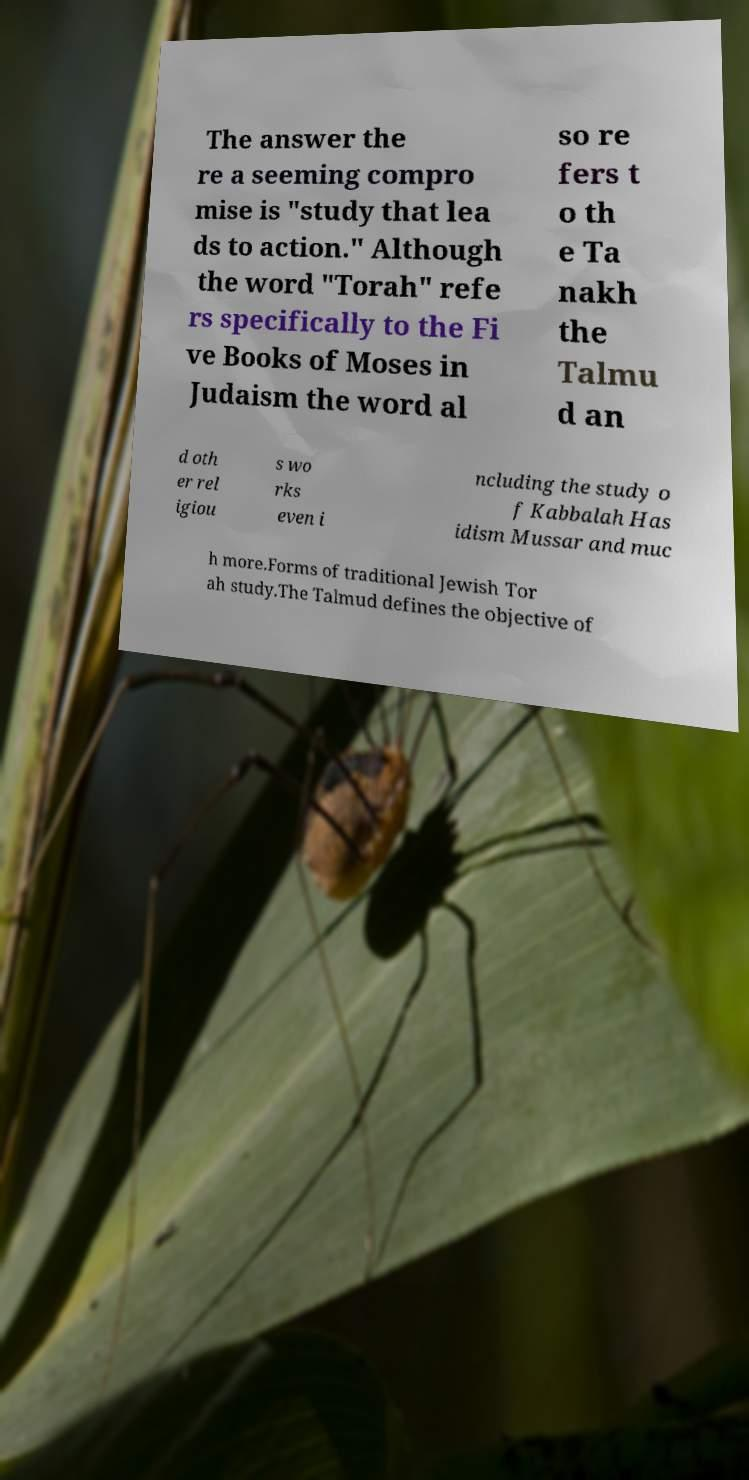Could you assist in decoding the text presented in this image and type it out clearly? The answer the re a seeming compro mise is "study that lea ds to action." Although the word "Torah" refe rs specifically to the Fi ve Books of Moses in Judaism the word al so re fers t o th e Ta nakh the Talmu d an d oth er rel igiou s wo rks even i ncluding the study o f Kabbalah Has idism Mussar and muc h more.Forms of traditional Jewish Tor ah study.The Talmud defines the objective of 